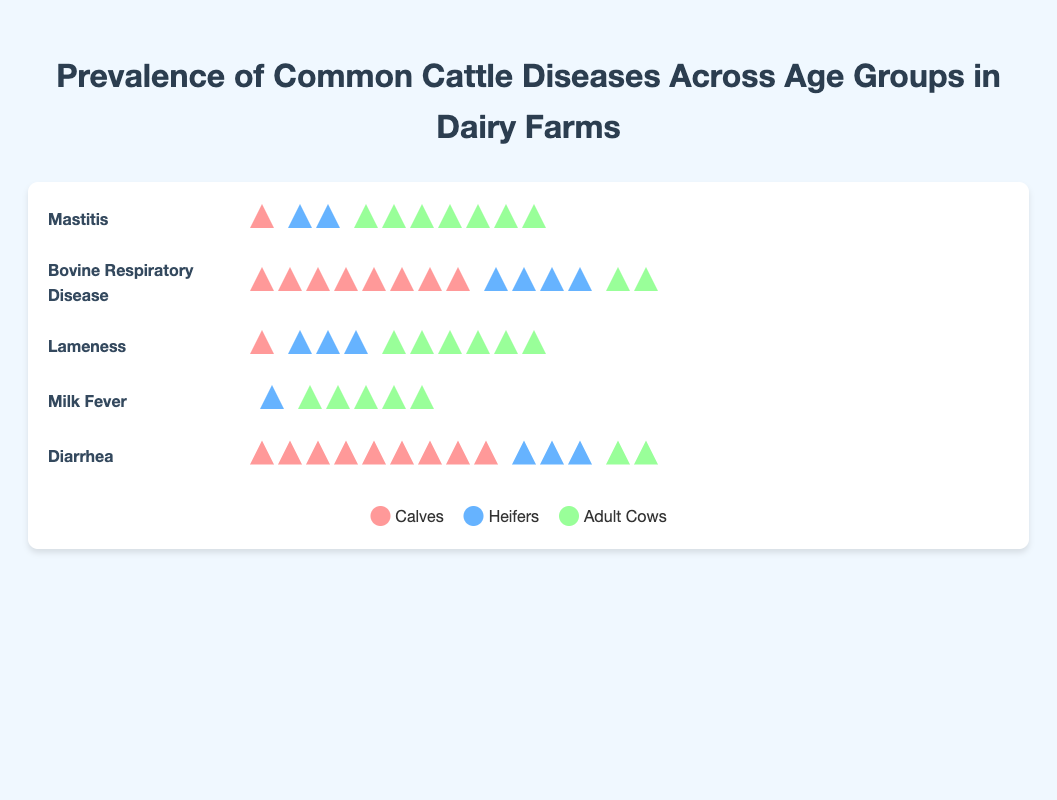which disease has the highest prevalence among adult cows? Mastitis has the highest prevalence among adult cows with 7 cases. This can be identified by visually counting the icons in the "adult cows" column for each disease and noting that Mastitis has the most.
Answer: Mastitis what is the prevalence of lameness in heifers? Count the icons in the "heifers" column for Lameness. There are 3 icons.
Answer: 3 how many more cases of diarrhea are there in calves compared to adult cows? Identify the number of icons in the "calves" and "adult cows" columns for Diarrhea. There are 9 icons for calves and 2 for adult cows. Subtract 2 from 9.
Answer: 7 which disease has zero prevalence in calves? By checking the "calves" column, we find that Milk Fever has zero icons.
Answer: Milk Fever compare the prevalence of bovine respiratory disease between calves and heifers. which group has more cases? Count the icons in the "calves" and "heifers" columns for Bovine Respiratory Disease. There are 8 icons for calves and 4 for heifers. Calves have more cases.
Answer: Calves what is the total number of mastitis cases across all age groups? Sum the number of icons in all columns for Mastitis. There are 1 (calves) + 2 (heifers) + 7 (adult cows) = 10 cases.
Answer: 10 for which disease do adult cows have a higher prevalence compared to calves? Compare the "adult cows" and "calves" columns for each disease. Adult cows have higher numbers in Mastitis (7 vs 1), Lameness (6 vs 1), and Milk Fever (5 vs 0).
Answer: Mastitis, Lameness, Milk Fever which age group has the highest overall prevalence of diseases? Sum the number of icons in each age group column across all diseases. Calves: 1 + 8 + 1 + 0 + 9 = 19, Heifers: 2 + 4  + 3 + 1 + 3 = 13, Adult cows: 7 + 2 + 6 + 5 + 2 = 22. Adult cows have the highest overall prevalence.
Answer: Adult cows 